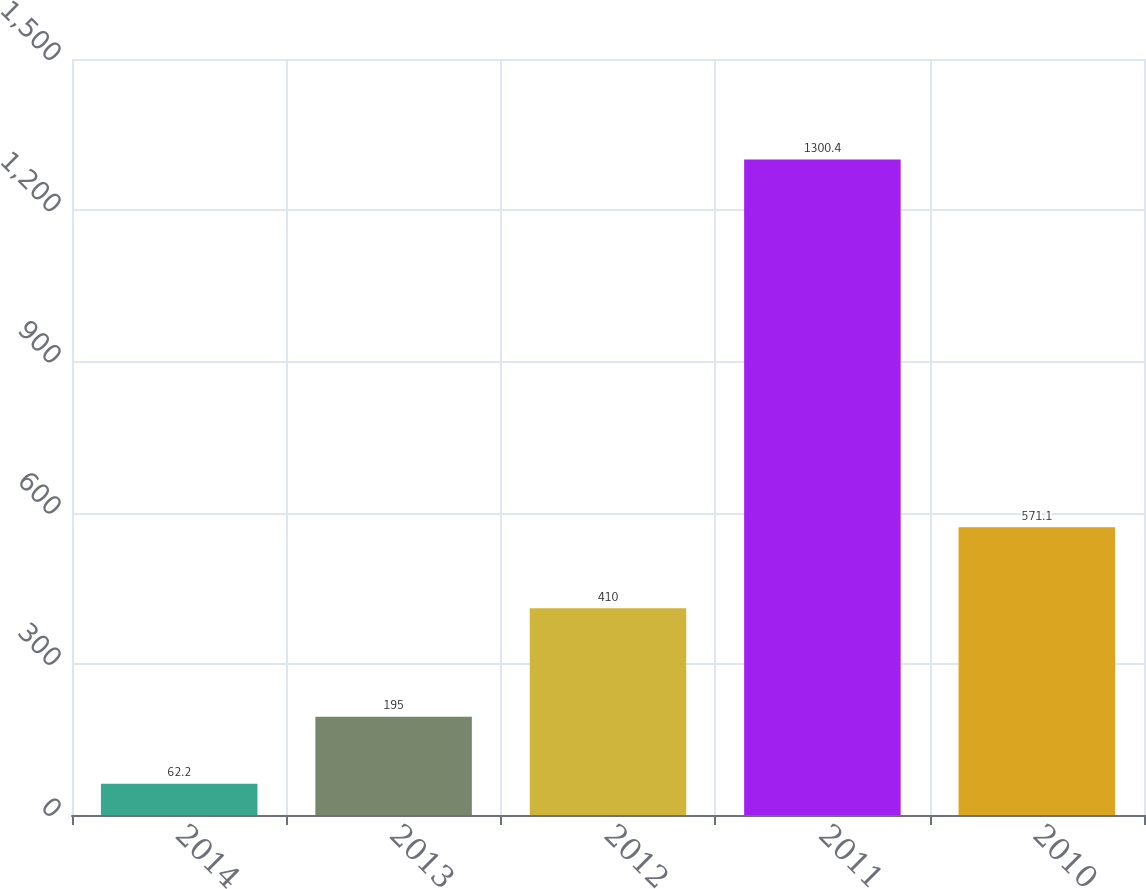Convert chart. <chart><loc_0><loc_0><loc_500><loc_500><bar_chart><fcel>2014<fcel>2013<fcel>2012<fcel>2011<fcel>2010<nl><fcel>62.2<fcel>195<fcel>410<fcel>1300.4<fcel>571.1<nl></chart> 